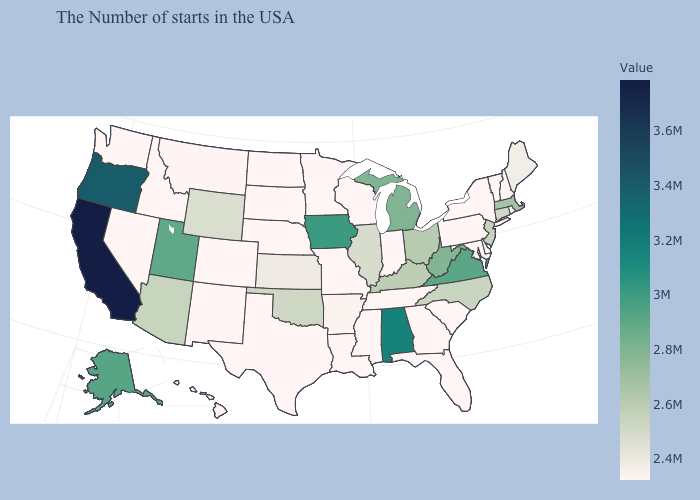Does Hawaii have the lowest value in the USA?
Answer briefly. Yes. Does South Dakota have a lower value than Oregon?
Write a very short answer. Yes. Among the states that border Arkansas , which have the lowest value?
Write a very short answer. Tennessee, Mississippi, Louisiana, Missouri, Texas. Which states have the lowest value in the West?
Give a very brief answer. Colorado, New Mexico, Idaho, Nevada, Washington, Hawaii. Which states have the highest value in the USA?
Short answer required. California. Among the states that border Arkansas , which have the lowest value?
Give a very brief answer. Tennessee, Mississippi, Louisiana, Missouri, Texas. Among the states that border Louisiana , does Mississippi have the highest value?
Concise answer only. No. 